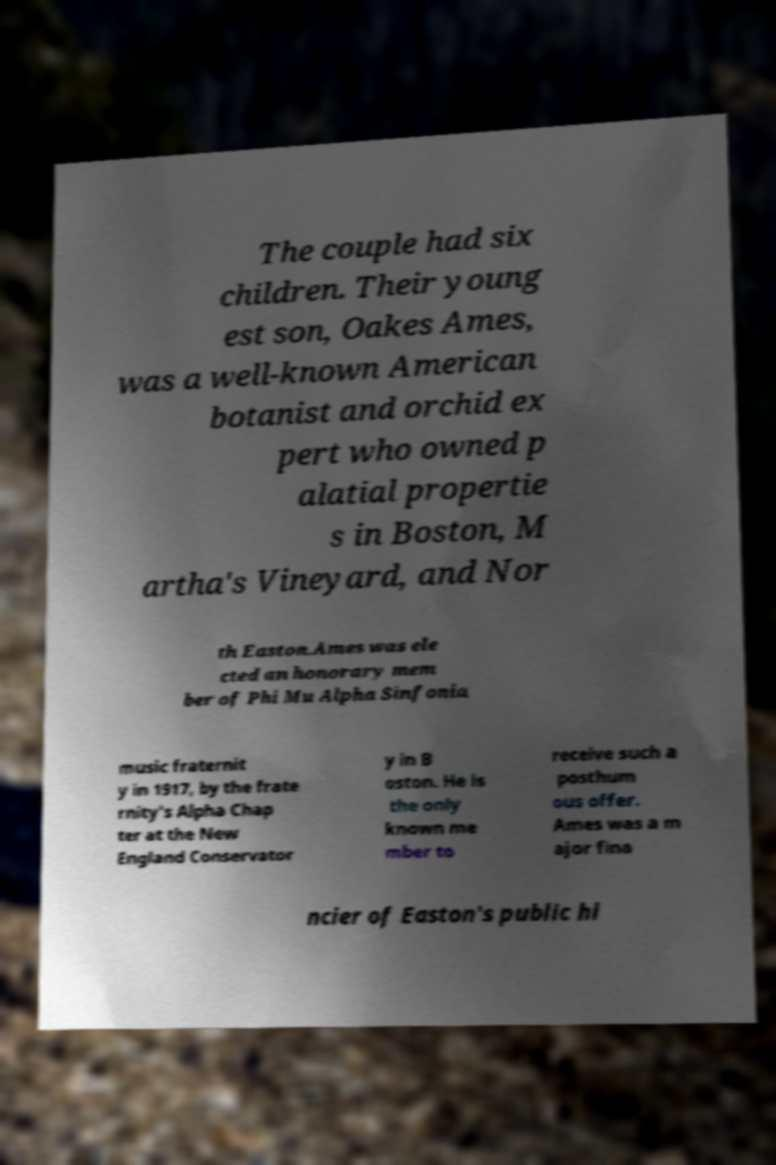Please read and relay the text visible in this image. What does it say? The couple had six children. Their young est son, Oakes Ames, was a well-known American botanist and orchid ex pert who owned p alatial propertie s in Boston, M artha's Vineyard, and Nor th Easton.Ames was ele cted an honorary mem ber of Phi Mu Alpha Sinfonia music fraternit y in 1917, by the frate rnity's Alpha Chap ter at the New England Conservator y in B oston. He is the only known me mber to receive such a posthum ous offer. Ames was a m ajor fina ncier of Easton's public hi 